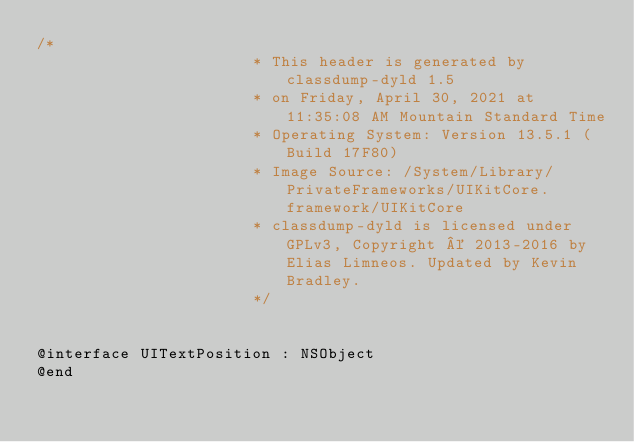<code> <loc_0><loc_0><loc_500><loc_500><_C_>/*
                       * This header is generated by classdump-dyld 1.5
                       * on Friday, April 30, 2021 at 11:35:08 AM Mountain Standard Time
                       * Operating System: Version 13.5.1 (Build 17F80)
                       * Image Source: /System/Library/PrivateFrameworks/UIKitCore.framework/UIKitCore
                       * classdump-dyld is licensed under GPLv3, Copyright © 2013-2016 by Elias Limneos. Updated by Kevin Bradley.
                       */


@interface UITextPosition : NSObject
@end

</code> 